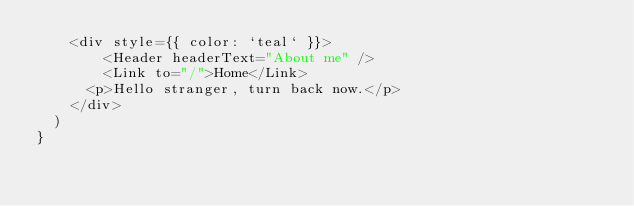<code> <loc_0><loc_0><loc_500><loc_500><_JavaScript_>    <div style={{ color: `teal` }}>
        <Header headerText="About me" />
        <Link to="/">Home</Link>
      <p>Hello stranger, turn back now.</p>
    </div>
  )
}</code> 